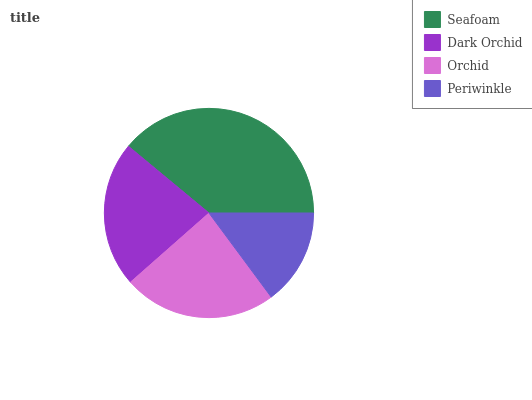Is Periwinkle the minimum?
Answer yes or no. Yes. Is Seafoam the maximum?
Answer yes or no. Yes. Is Dark Orchid the minimum?
Answer yes or no. No. Is Dark Orchid the maximum?
Answer yes or no. No. Is Seafoam greater than Dark Orchid?
Answer yes or no. Yes. Is Dark Orchid less than Seafoam?
Answer yes or no. Yes. Is Dark Orchid greater than Seafoam?
Answer yes or no. No. Is Seafoam less than Dark Orchid?
Answer yes or no. No. Is Orchid the high median?
Answer yes or no. Yes. Is Dark Orchid the low median?
Answer yes or no. Yes. Is Periwinkle the high median?
Answer yes or no. No. Is Seafoam the low median?
Answer yes or no. No. 